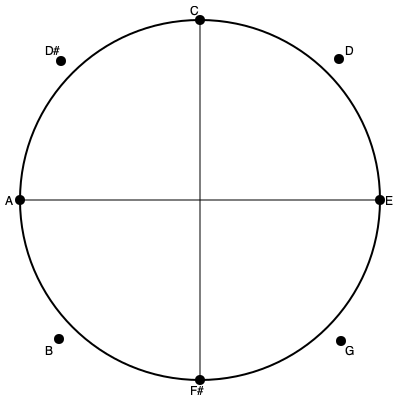In this geometric representation of a musical scale, which symmetry operation would transform the C-E-G augmented triad into the F#-A-C augmented triad? To solve this problem, let's follow these steps:

1. Identify the notes in the given triads:
   - C-E-G augmented triad
   - F#-A-C augmented triad

2. Observe the geometric representation:
   - The notes are arranged on a circle, representing the chromatic scale.
   - The circle is divided into 12 equal parts, each representing a semitone.

3. Analyze the relationship between the triads:
   - C-E-G forms an equilateral triangle in the circle.
   - F#-A-C also forms an equilateral triangle in the circle.
   - These triangles are exact opposites on the circle.

4. Consider possible symmetry operations:
   - Rotation: This would not transform one triad into the other.
   - Reflection: This also would not work for this transformation.
   - Inversion: This operation would flip the triangle through the center point.

5. Apply the inversion operation:
   - Inverting C gives F# (opposite point on the circle)
   - Inverting E gives A
   - Inverting G gives C

6. Conclusion:
   The symmetry operation that transforms C-E-G into F#-A-C is inversion through the center of the circle.

In musical terms, this inversion corresponds to the interval of a tritone (augmented fourth or diminished fifth), which is represented by the diameter of the circle in this geometric model.
Answer: Inversion 